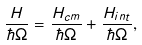Convert formula to latex. <formula><loc_0><loc_0><loc_500><loc_500>\frac { H } { \hbar { \Omega } } = \frac { H _ { c m } } { \hbar { \Omega } } + \frac { H _ { i n t } } { \hbar { \Omega } } ,</formula> 